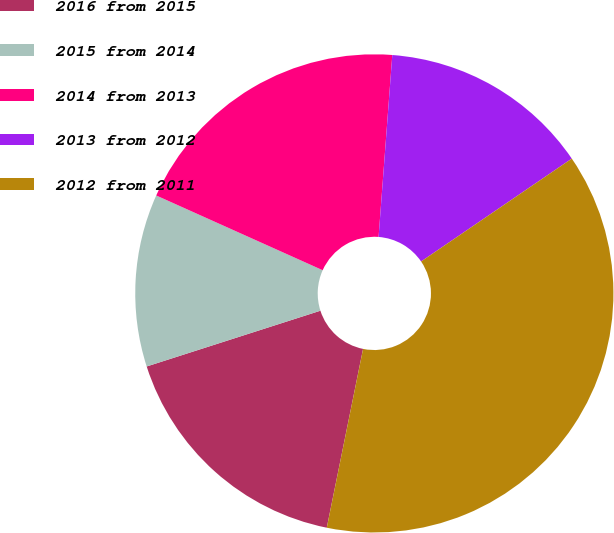<chart> <loc_0><loc_0><loc_500><loc_500><pie_chart><fcel>2016 from 2015<fcel>2015 from 2014<fcel>2014 from 2013<fcel>2013 from 2012<fcel>2012 from 2011<nl><fcel>16.87%<fcel>11.66%<fcel>19.48%<fcel>14.27%<fcel>37.72%<nl></chart> 